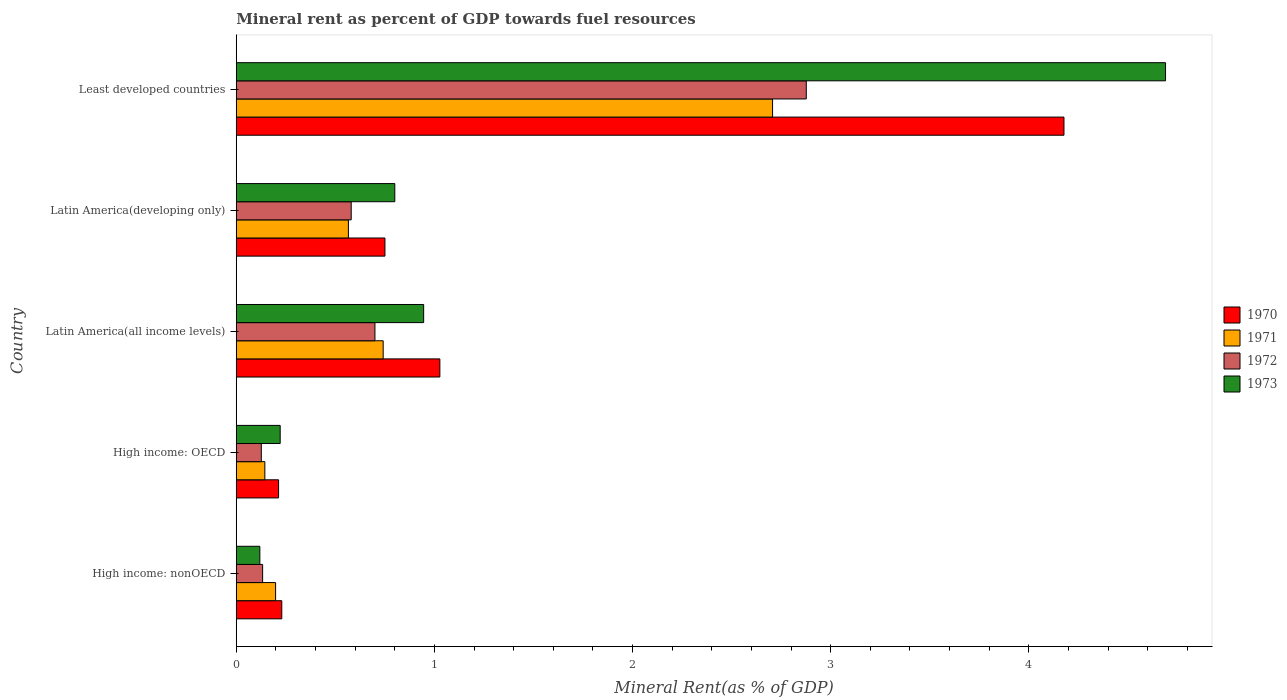How many different coloured bars are there?
Give a very brief answer. 4. Are the number of bars on each tick of the Y-axis equal?
Give a very brief answer. Yes. How many bars are there on the 4th tick from the top?
Offer a very short reply. 4. How many bars are there on the 1st tick from the bottom?
Your answer should be very brief. 4. What is the label of the 5th group of bars from the top?
Your answer should be compact. High income: nonOECD. What is the mineral rent in 1970 in High income: nonOECD?
Offer a terse response. 0.23. Across all countries, what is the maximum mineral rent in 1970?
Your answer should be compact. 4.18. Across all countries, what is the minimum mineral rent in 1971?
Give a very brief answer. 0.14. In which country was the mineral rent in 1970 maximum?
Your response must be concise. Least developed countries. In which country was the mineral rent in 1971 minimum?
Make the answer very short. High income: OECD. What is the total mineral rent in 1970 in the graph?
Offer a terse response. 6.4. What is the difference between the mineral rent in 1970 in High income: nonOECD and that in Latin America(developing only)?
Your response must be concise. -0.52. What is the difference between the mineral rent in 1971 in Latin America(all income levels) and the mineral rent in 1970 in Least developed countries?
Give a very brief answer. -3.44. What is the average mineral rent in 1972 per country?
Make the answer very short. 0.88. What is the difference between the mineral rent in 1970 and mineral rent in 1972 in Latin America(all income levels)?
Offer a very short reply. 0.33. What is the ratio of the mineral rent in 1971 in High income: nonOECD to that in Latin America(developing only)?
Your answer should be very brief. 0.35. Is the difference between the mineral rent in 1970 in Latin America(all income levels) and Latin America(developing only) greater than the difference between the mineral rent in 1972 in Latin America(all income levels) and Latin America(developing only)?
Ensure brevity in your answer.  Yes. What is the difference between the highest and the second highest mineral rent in 1972?
Offer a very short reply. 2.18. What is the difference between the highest and the lowest mineral rent in 1971?
Offer a very short reply. 2.56. Is the sum of the mineral rent in 1973 in High income: nonOECD and Least developed countries greater than the maximum mineral rent in 1971 across all countries?
Give a very brief answer. Yes. Is it the case that in every country, the sum of the mineral rent in 1973 and mineral rent in 1972 is greater than the sum of mineral rent in 1971 and mineral rent in 1970?
Your answer should be compact. No. Is it the case that in every country, the sum of the mineral rent in 1970 and mineral rent in 1971 is greater than the mineral rent in 1973?
Keep it short and to the point. Yes. How many countries are there in the graph?
Offer a terse response. 5. Does the graph contain any zero values?
Ensure brevity in your answer.  No. Does the graph contain grids?
Provide a succinct answer. No. Where does the legend appear in the graph?
Offer a very short reply. Center right. What is the title of the graph?
Make the answer very short. Mineral rent as percent of GDP towards fuel resources. Does "2009" appear as one of the legend labels in the graph?
Make the answer very short. No. What is the label or title of the X-axis?
Provide a short and direct response. Mineral Rent(as % of GDP). What is the label or title of the Y-axis?
Give a very brief answer. Country. What is the Mineral Rent(as % of GDP) of 1970 in High income: nonOECD?
Make the answer very short. 0.23. What is the Mineral Rent(as % of GDP) in 1971 in High income: nonOECD?
Your response must be concise. 0.2. What is the Mineral Rent(as % of GDP) in 1972 in High income: nonOECD?
Your answer should be compact. 0.13. What is the Mineral Rent(as % of GDP) of 1973 in High income: nonOECD?
Make the answer very short. 0.12. What is the Mineral Rent(as % of GDP) of 1970 in High income: OECD?
Give a very brief answer. 0.21. What is the Mineral Rent(as % of GDP) in 1971 in High income: OECD?
Make the answer very short. 0.14. What is the Mineral Rent(as % of GDP) in 1972 in High income: OECD?
Your response must be concise. 0.13. What is the Mineral Rent(as % of GDP) of 1973 in High income: OECD?
Provide a succinct answer. 0.22. What is the Mineral Rent(as % of GDP) in 1970 in Latin America(all income levels)?
Offer a very short reply. 1.03. What is the Mineral Rent(as % of GDP) in 1971 in Latin America(all income levels)?
Make the answer very short. 0.74. What is the Mineral Rent(as % of GDP) in 1972 in Latin America(all income levels)?
Provide a succinct answer. 0.7. What is the Mineral Rent(as % of GDP) of 1973 in Latin America(all income levels)?
Give a very brief answer. 0.95. What is the Mineral Rent(as % of GDP) in 1970 in Latin America(developing only)?
Your answer should be compact. 0.75. What is the Mineral Rent(as % of GDP) in 1971 in Latin America(developing only)?
Give a very brief answer. 0.57. What is the Mineral Rent(as % of GDP) in 1972 in Latin America(developing only)?
Give a very brief answer. 0.58. What is the Mineral Rent(as % of GDP) of 1973 in Latin America(developing only)?
Keep it short and to the point. 0.8. What is the Mineral Rent(as % of GDP) of 1970 in Least developed countries?
Make the answer very short. 4.18. What is the Mineral Rent(as % of GDP) in 1971 in Least developed countries?
Provide a succinct answer. 2.71. What is the Mineral Rent(as % of GDP) of 1972 in Least developed countries?
Make the answer very short. 2.88. What is the Mineral Rent(as % of GDP) of 1973 in Least developed countries?
Your answer should be compact. 4.69. Across all countries, what is the maximum Mineral Rent(as % of GDP) in 1970?
Offer a very short reply. 4.18. Across all countries, what is the maximum Mineral Rent(as % of GDP) of 1971?
Your response must be concise. 2.71. Across all countries, what is the maximum Mineral Rent(as % of GDP) in 1972?
Ensure brevity in your answer.  2.88. Across all countries, what is the maximum Mineral Rent(as % of GDP) in 1973?
Your response must be concise. 4.69. Across all countries, what is the minimum Mineral Rent(as % of GDP) of 1970?
Keep it short and to the point. 0.21. Across all countries, what is the minimum Mineral Rent(as % of GDP) in 1971?
Offer a terse response. 0.14. Across all countries, what is the minimum Mineral Rent(as % of GDP) of 1972?
Provide a short and direct response. 0.13. Across all countries, what is the minimum Mineral Rent(as % of GDP) of 1973?
Make the answer very short. 0.12. What is the total Mineral Rent(as % of GDP) in 1970 in the graph?
Keep it short and to the point. 6.4. What is the total Mineral Rent(as % of GDP) of 1971 in the graph?
Ensure brevity in your answer.  4.36. What is the total Mineral Rent(as % of GDP) in 1972 in the graph?
Your answer should be very brief. 4.42. What is the total Mineral Rent(as % of GDP) in 1973 in the graph?
Keep it short and to the point. 6.78. What is the difference between the Mineral Rent(as % of GDP) in 1970 in High income: nonOECD and that in High income: OECD?
Provide a short and direct response. 0.02. What is the difference between the Mineral Rent(as % of GDP) of 1971 in High income: nonOECD and that in High income: OECD?
Provide a succinct answer. 0.05. What is the difference between the Mineral Rent(as % of GDP) of 1972 in High income: nonOECD and that in High income: OECD?
Your answer should be compact. 0.01. What is the difference between the Mineral Rent(as % of GDP) in 1973 in High income: nonOECD and that in High income: OECD?
Offer a terse response. -0.1. What is the difference between the Mineral Rent(as % of GDP) of 1970 in High income: nonOECD and that in Latin America(all income levels)?
Make the answer very short. -0.8. What is the difference between the Mineral Rent(as % of GDP) in 1971 in High income: nonOECD and that in Latin America(all income levels)?
Give a very brief answer. -0.54. What is the difference between the Mineral Rent(as % of GDP) in 1972 in High income: nonOECD and that in Latin America(all income levels)?
Your response must be concise. -0.57. What is the difference between the Mineral Rent(as % of GDP) of 1973 in High income: nonOECD and that in Latin America(all income levels)?
Offer a very short reply. -0.83. What is the difference between the Mineral Rent(as % of GDP) in 1970 in High income: nonOECD and that in Latin America(developing only)?
Keep it short and to the point. -0.52. What is the difference between the Mineral Rent(as % of GDP) of 1971 in High income: nonOECD and that in Latin America(developing only)?
Ensure brevity in your answer.  -0.37. What is the difference between the Mineral Rent(as % of GDP) of 1972 in High income: nonOECD and that in Latin America(developing only)?
Ensure brevity in your answer.  -0.45. What is the difference between the Mineral Rent(as % of GDP) in 1973 in High income: nonOECD and that in Latin America(developing only)?
Make the answer very short. -0.68. What is the difference between the Mineral Rent(as % of GDP) of 1970 in High income: nonOECD and that in Least developed countries?
Make the answer very short. -3.95. What is the difference between the Mineral Rent(as % of GDP) in 1971 in High income: nonOECD and that in Least developed countries?
Make the answer very short. -2.51. What is the difference between the Mineral Rent(as % of GDP) of 1972 in High income: nonOECD and that in Least developed countries?
Your answer should be very brief. -2.74. What is the difference between the Mineral Rent(as % of GDP) in 1973 in High income: nonOECD and that in Least developed countries?
Make the answer very short. -4.57. What is the difference between the Mineral Rent(as % of GDP) in 1970 in High income: OECD and that in Latin America(all income levels)?
Your response must be concise. -0.81. What is the difference between the Mineral Rent(as % of GDP) in 1971 in High income: OECD and that in Latin America(all income levels)?
Give a very brief answer. -0.6. What is the difference between the Mineral Rent(as % of GDP) in 1972 in High income: OECD and that in Latin America(all income levels)?
Offer a very short reply. -0.57. What is the difference between the Mineral Rent(as % of GDP) in 1973 in High income: OECD and that in Latin America(all income levels)?
Provide a short and direct response. -0.72. What is the difference between the Mineral Rent(as % of GDP) of 1970 in High income: OECD and that in Latin America(developing only)?
Offer a very short reply. -0.54. What is the difference between the Mineral Rent(as % of GDP) in 1971 in High income: OECD and that in Latin America(developing only)?
Provide a short and direct response. -0.42. What is the difference between the Mineral Rent(as % of GDP) in 1972 in High income: OECD and that in Latin America(developing only)?
Your answer should be very brief. -0.45. What is the difference between the Mineral Rent(as % of GDP) in 1973 in High income: OECD and that in Latin America(developing only)?
Offer a very short reply. -0.58. What is the difference between the Mineral Rent(as % of GDP) of 1970 in High income: OECD and that in Least developed countries?
Offer a very short reply. -3.96. What is the difference between the Mineral Rent(as % of GDP) in 1971 in High income: OECD and that in Least developed countries?
Your answer should be very brief. -2.56. What is the difference between the Mineral Rent(as % of GDP) in 1972 in High income: OECD and that in Least developed countries?
Offer a terse response. -2.75. What is the difference between the Mineral Rent(as % of GDP) of 1973 in High income: OECD and that in Least developed countries?
Offer a very short reply. -4.47. What is the difference between the Mineral Rent(as % of GDP) of 1970 in Latin America(all income levels) and that in Latin America(developing only)?
Your answer should be very brief. 0.28. What is the difference between the Mineral Rent(as % of GDP) in 1971 in Latin America(all income levels) and that in Latin America(developing only)?
Give a very brief answer. 0.18. What is the difference between the Mineral Rent(as % of GDP) of 1972 in Latin America(all income levels) and that in Latin America(developing only)?
Offer a very short reply. 0.12. What is the difference between the Mineral Rent(as % of GDP) of 1973 in Latin America(all income levels) and that in Latin America(developing only)?
Your response must be concise. 0.15. What is the difference between the Mineral Rent(as % of GDP) of 1970 in Latin America(all income levels) and that in Least developed countries?
Ensure brevity in your answer.  -3.15. What is the difference between the Mineral Rent(as % of GDP) of 1971 in Latin America(all income levels) and that in Least developed countries?
Provide a succinct answer. -1.97. What is the difference between the Mineral Rent(as % of GDP) in 1972 in Latin America(all income levels) and that in Least developed countries?
Make the answer very short. -2.18. What is the difference between the Mineral Rent(as % of GDP) in 1973 in Latin America(all income levels) and that in Least developed countries?
Provide a short and direct response. -3.74. What is the difference between the Mineral Rent(as % of GDP) of 1970 in Latin America(developing only) and that in Least developed countries?
Offer a terse response. -3.43. What is the difference between the Mineral Rent(as % of GDP) of 1971 in Latin America(developing only) and that in Least developed countries?
Give a very brief answer. -2.14. What is the difference between the Mineral Rent(as % of GDP) in 1972 in Latin America(developing only) and that in Least developed countries?
Your answer should be compact. -2.3. What is the difference between the Mineral Rent(as % of GDP) in 1973 in Latin America(developing only) and that in Least developed countries?
Provide a succinct answer. -3.89. What is the difference between the Mineral Rent(as % of GDP) in 1970 in High income: nonOECD and the Mineral Rent(as % of GDP) in 1971 in High income: OECD?
Provide a short and direct response. 0.09. What is the difference between the Mineral Rent(as % of GDP) in 1970 in High income: nonOECD and the Mineral Rent(as % of GDP) in 1972 in High income: OECD?
Provide a succinct answer. 0.1. What is the difference between the Mineral Rent(as % of GDP) of 1970 in High income: nonOECD and the Mineral Rent(as % of GDP) of 1973 in High income: OECD?
Offer a very short reply. 0.01. What is the difference between the Mineral Rent(as % of GDP) in 1971 in High income: nonOECD and the Mineral Rent(as % of GDP) in 1972 in High income: OECD?
Your response must be concise. 0.07. What is the difference between the Mineral Rent(as % of GDP) of 1971 in High income: nonOECD and the Mineral Rent(as % of GDP) of 1973 in High income: OECD?
Your answer should be compact. -0.02. What is the difference between the Mineral Rent(as % of GDP) in 1972 in High income: nonOECD and the Mineral Rent(as % of GDP) in 1973 in High income: OECD?
Offer a terse response. -0.09. What is the difference between the Mineral Rent(as % of GDP) in 1970 in High income: nonOECD and the Mineral Rent(as % of GDP) in 1971 in Latin America(all income levels)?
Provide a succinct answer. -0.51. What is the difference between the Mineral Rent(as % of GDP) in 1970 in High income: nonOECD and the Mineral Rent(as % of GDP) in 1972 in Latin America(all income levels)?
Provide a succinct answer. -0.47. What is the difference between the Mineral Rent(as % of GDP) of 1970 in High income: nonOECD and the Mineral Rent(as % of GDP) of 1973 in Latin America(all income levels)?
Offer a very short reply. -0.72. What is the difference between the Mineral Rent(as % of GDP) of 1971 in High income: nonOECD and the Mineral Rent(as % of GDP) of 1972 in Latin America(all income levels)?
Your answer should be compact. -0.5. What is the difference between the Mineral Rent(as % of GDP) in 1971 in High income: nonOECD and the Mineral Rent(as % of GDP) in 1973 in Latin America(all income levels)?
Make the answer very short. -0.75. What is the difference between the Mineral Rent(as % of GDP) of 1972 in High income: nonOECD and the Mineral Rent(as % of GDP) of 1973 in Latin America(all income levels)?
Offer a terse response. -0.81. What is the difference between the Mineral Rent(as % of GDP) of 1970 in High income: nonOECD and the Mineral Rent(as % of GDP) of 1971 in Latin America(developing only)?
Provide a short and direct response. -0.34. What is the difference between the Mineral Rent(as % of GDP) in 1970 in High income: nonOECD and the Mineral Rent(as % of GDP) in 1972 in Latin America(developing only)?
Your answer should be compact. -0.35. What is the difference between the Mineral Rent(as % of GDP) in 1970 in High income: nonOECD and the Mineral Rent(as % of GDP) in 1973 in Latin America(developing only)?
Provide a succinct answer. -0.57. What is the difference between the Mineral Rent(as % of GDP) of 1971 in High income: nonOECD and the Mineral Rent(as % of GDP) of 1972 in Latin America(developing only)?
Provide a short and direct response. -0.38. What is the difference between the Mineral Rent(as % of GDP) in 1971 in High income: nonOECD and the Mineral Rent(as % of GDP) in 1973 in Latin America(developing only)?
Your answer should be very brief. -0.6. What is the difference between the Mineral Rent(as % of GDP) in 1972 in High income: nonOECD and the Mineral Rent(as % of GDP) in 1973 in Latin America(developing only)?
Your response must be concise. -0.67. What is the difference between the Mineral Rent(as % of GDP) in 1970 in High income: nonOECD and the Mineral Rent(as % of GDP) in 1971 in Least developed countries?
Offer a terse response. -2.48. What is the difference between the Mineral Rent(as % of GDP) of 1970 in High income: nonOECD and the Mineral Rent(as % of GDP) of 1972 in Least developed countries?
Your answer should be very brief. -2.65. What is the difference between the Mineral Rent(as % of GDP) in 1970 in High income: nonOECD and the Mineral Rent(as % of GDP) in 1973 in Least developed countries?
Your answer should be very brief. -4.46. What is the difference between the Mineral Rent(as % of GDP) of 1971 in High income: nonOECD and the Mineral Rent(as % of GDP) of 1972 in Least developed countries?
Provide a short and direct response. -2.68. What is the difference between the Mineral Rent(as % of GDP) of 1971 in High income: nonOECD and the Mineral Rent(as % of GDP) of 1973 in Least developed countries?
Your answer should be very brief. -4.49. What is the difference between the Mineral Rent(as % of GDP) of 1972 in High income: nonOECD and the Mineral Rent(as % of GDP) of 1973 in Least developed countries?
Your answer should be compact. -4.56. What is the difference between the Mineral Rent(as % of GDP) of 1970 in High income: OECD and the Mineral Rent(as % of GDP) of 1971 in Latin America(all income levels)?
Ensure brevity in your answer.  -0.53. What is the difference between the Mineral Rent(as % of GDP) in 1970 in High income: OECD and the Mineral Rent(as % of GDP) in 1972 in Latin America(all income levels)?
Keep it short and to the point. -0.49. What is the difference between the Mineral Rent(as % of GDP) in 1970 in High income: OECD and the Mineral Rent(as % of GDP) in 1973 in Latin America(all income levels)?
Provide a short and direct response. -0.73. What is the difference between the Mineral Rent(as % of GDP) in 1971 in High income: OECD and the Mineral Rent(as % of GDP) in 1972 in Latin America(all income levels)?
Your answer should be compact. -0.56. What is the difference between the Mineral Rent(as % of GDP) in 1971 in High income: OECD and the Mineral Rent(as % of GDP) in 1973 in Latin America(all income levels)?
Your response must be concise. -0.8. What is the difference between the Mineral Rent(as % of GDP) in 1972 in High income: OECD and the Mineral Rent(as % of GDP) in 1973 in Latin America(all income levels)?
Your answer should be very brief. -0.82. What is the difference between the Mineral Rent(as % of GDP) of 1970 in High income: OECD and the Mineral Rent(as % of GDP) of 1971 in Latin America(developing only)?
Provide a short and direct response. -0.35. What is the difference between the Mineral Rent(as % of GDP) in 1970 in High income: OECD and the Mineral Rent(as % of GDP) in 1972 in Latin America(developing only)?
Offer a very short reply. -0.37. What is the difference between the Mineral Rent(as % of GDP) in 1970 in High income: OECD and the Mineral Rent(as % of GDP) in 1973 in Latin America(developing only)?
Give a very brief answer. -0.59. What is the difference between the Mineral Rent(as % of GDP) in 1971 in High income: OECD and the Mineral Rent(as % of GDP) in 1972 in Latin America(developing only)?
Provide a short and direct response. -0.44. What is the difference between the Mineral Rent(as % of GDP) of 1971 in High income: OECD and the Mineral Rent(as % of GDP) of 1973 in Latin America(developing only)?
Your response must be concise. -0.66. What is the difference between the Mineral Rent(as % of GDP) of 1972 in High income: OECD and the Mineral Rent(as % of GDP) of 1973 in Latin America(developing only)?
Offer a very short reply. -0.67. What is the difference between the Mineral Rent(as % of GDP) of 1970 in High income: OECD and the Mineral Rent(as % of GDP) of 1971 in Least developed countries?
Give a very brief answer. -2.49. What is the difference between the Mineral Rent(as % of GDP) of 1970 in High income: OECD and the Mineral Rent(as % of GDP) of 1972 in Least developed countries?
Provide a short and direct response. -2.66. What is the difference between the Mineral Rent(as % of GDP) of 1970 in High income: OECD and the Mineral Rent(as % of GDP) of 1973 in Least developed countries?
Your answer should be very brief. -4.48. What is the difference between the Mineral Rent(as % of GDP) in 1971 in High income: OECD and the Mineral Rent(as % of GDP) in 1972 in Least developed countries?
Your answer should be very brief. -2.73. What is the difference between the Mineral Rent(as % of GDP) of 1971 in High income: OECD and the Mineral Rent(as % of GDP) of 1973 in Least developed countries?
Make the answer very short. -4.55. What is the difference between the Mineral Rent(as % of GDP) of 1972 in High income: OECD and the Mineral Rent(as % of GDP) of 1973 in Least developed countries?
Your response must be concise. -4.56. What is the difference between the Mineral Rent(as % of GDP) of 1970 in Latin America(all income levels) and the Mineral Rent(as % of GDP) of 1971 in Latin America(developing only)?
Your answer should be compact. 0.46. What is the difference between the Mineral Rent(as % of GDP) in 1970 in Latin America(all income levels) and the Mineral Rent(as % of GDP) in 1972 in Latin America(developing only)?
Make the answer very short. 0.45. What is the difference between the Mineral Rent(as % of GDP) of 1970 in Latin America(all income levels) and the Mineral Rent(as % of GDP) of 1973 in Latin America(developing only)?
Make the answer very short. 0.23. What is the difference between the Mineral Rent(as % of GDP) in 1971 in Latin America(all income levels) and the Mineral Rent(as % of GDP) in 1972 in Latin America(developing only)?
Offer a terse response. 0.16. What is the difference between the Mineral Rent(as % of GDP) of 1971 in Latin America(all income levels) and the Mineral Rent(as % of GDP) of 1973 in Latin America(developing only)?
Provide a short and direct response. -0.06. What is the difference between the Mineral Rent(as % of GDP) in 1972 in Latin America(all income levels) and the Mineral Rent(as % of GDP) in 1973 in Latin America(developing only)?
Ensure brevity in your answer.  -0.1. What is the difference between the Mineral Rent(as % of GDP) of 1970 in Latin America(all income levels) and the Mineral Rent(as % of GDP) of 1971 in Least developed countries?
Make the answer very short. -1.68. What is the difference between the Mineral Rent(as % of GDP) in 1970 in Latin America(all income levels) and the Mineral Rent(as % of GDP) in 1972 in Least developed countries?
Ensure brevity in your answer.  -1.85. What is the difference between the Mineral Rent(as % of GDP) of 1970 in Latin America(all income levels) and the Mineral Rent(as % of GDP) of 1973 in Least developed countries?
Your answer should be very brief. -3.66. What is the difference between the Mineral Rent(as % of GDP) of 1971 in Latin America(all income levels) and the Mineral Rent(as % of GDP) of 1972 in Least developed countries?
Offer a terse response. -2.14. What is the difference between the Mineral Rent(as % of GDP) in 1971 in Latin America(all income levels) and the Mineral Rent(as % of GDP) in 1973 in Least developed countries?
Keep it short and to the point. -3.95. What is the difference between the Mineral Rent(as % of GDP) in 1972 in Latin America(all income levels) and the Mineral Rent(as % of GDP) in 1973 in Least developed countries?
Offer a terse response. -3.99. What is the difference between the Mineral Rent(as % of GDP) of 1970 in Latin America(developing only) and the Mineral Rent(as % of GDP) of 1971 in Least developed countries?
Your answer should be very brief. -1.96. What is the difference between the Mineral Rent(as % of GDP) in 1970 in Latin America(developing only) and the Mineral Rent(as % of GDP) in 1972 in Least developed countries?
Ensure brevity in your answer.  -2.13. What is the difference between the Mineral Rent(as % of GDP) in 1970 in Latin America(developing only) and the Mineral Rent(as % of GDP) in 1973 in Least developed countries?
Offer a very short reply. -3.94. What is the difference between the Mineral Rent(as % of GDP) in 1971 in Latin America(developing only) and the Mineral Rent(as % of GDP) in 1972 in Least developed countries?
Offer a terse response. -2.31. What is the difference between the Mineral Rent(as % of GDP) in 1971 in Latin America(developing only) and the Mineral Rent(as % of GDP) in 1973 in Least developed countries?
Offer a very short reply. -4.12. What is the difference between the Mineral Rent(as % of GDP) of 1972 in Latin America(developing only) and the Mineral Rent(as % of GDP) of 1973 in Least developed countries?
Make the answer very short. -4.11. What is the average Mineral Rent(as % of GDP) of 1970 per country?
Keep it short and to the point. 1.28. What is the average Mineral Rent(as % of GDP) in 1971 per country?
Give a very brief answer. 0.87. What is the average Mineral Rent(as % of GDP) of 1972 per country?
Give a very brief answer. 0.88. What is the average Mineral Rent(as % of GDP) of 1973 per country?
Your response must be concise. 1.36. What is the difference between the Mineral Rent(as % of GDP) of 1970 and Mineral Rent(as % of GDP) of 1971 in High income: nonOECD?
Offer a very short reply. 0.03. What is the difference between the Mineral Rent(as % of GDP) in 1970 and Mineral Rent(as % of GDP) in 1972 in High income: nonOECD?
Your answer should be compact. 0.1. What is the difference between the Mineral Rent(as % of GDP) of 1970 and Mineral Rent(as % of GDP) of 1973 in High income: nonOECD?
Your answer should be very brief. 0.11. What is the difference between the Mineral Rent(as % of GDP) in 1971 and Mineral Rent(as % of GDP) in 1972 in High income: nonOECD?
Ensure brevity in your answer.  0.07. What is the difference between the Mineral Rent(as % of GDP) in 1971 and Mineral Rent(as % of GDP) in 1973 in High income: nonOECD?
Offer a very short reply. 0.08. What is the difference between the Mineral Rent(as % of GDP) in 1972 and Mineral Rent(as % of GDP) in 1973 in High income: nonOECD?
Ensure brevity in your answer.  0.01. What is the difference between the Mineral Rent(as % of GDP) of 1970 and Mineral Rent(as % of GDP) of 1971 in High income: OECD?
Ensure brevity in your answer.  0.07. What is the difference between the Mineral Rent(as % of GDP) in 1970 and Mineral Rent(as % of GDP) in 1972 in High income: OECD?
Offer a very short reply. 0.09. What is the difference between the Mineral Rent(as % of GDP) in 1970 and Mineral Rent(as % of GDP) in 1973 in High income: OECD?
Your response must be concise. -0.01. What is the difference between the Mineral Rent(as % of GDP) in 1971 and Mineral Rent(as % of GDP) in 1972 in High income: OECD?
Provide a short and direct response. 0.02. What is the difference between the Mineral Rent(as % of GDP) in 1971 and Mineral Rent(as % of GDP) in 1973 in High income: OECD?
Offer a terse response. -0.08. What is the difference between the Mineral Rent(as % of GDP) in 1972 and Mineral Rent(as % of GDP) in 1973 in High income: OECD?
Provide a succinct answer. -0.1. What is the difference between the Mineral Rent(as % of GDP) of 1970 and Mineral Rent(as % of GDP) of 1971 in Latin America(all income levels)?
Your answer should be compact. 0.29. What is the difference between the Mineral Rent(as % of GDP) in 1970 and Mineral Rent(as % of GDP) in 1972 in Latin America(all income levels)?
Offer a terse response. 0.33. What is the difference between the Mineral Rent(as % of GDP) in 1970 and Mineral Rent(as % of GDP) in 1973 in Latin America(all income levels)?
Provide a short and direct response. 0.08. What is the difference between the Mineral Rent(as % of GDP) in 1971 and Mineral Rent(as % of GDP) in 1972 in Latin America(all income levels)?
Provide a short and direct response. 0.04. What is the difference between the Mineral Rent(as % of GDP) of 1971 and Mineral Rent(as % of GDP) of 1973 in Latin America(all income levels)?
Provide a succinct answer. -0.2. What is the difference between the Mineral Rent(as % of GDP) of 1972 and Mineral Rent(as % of GDP) of 1973 in Latin America(all income levels)?
Provide a succinct answer. -0.25. What is the difference between the Mineral Rent(as % of GDP) in 1970 and Mineral Rent(as % of GDP) in 1971 in Latin America(developing only)?
Keep it short and to the point. 0.18. What is the difference between the Mineral Rent(as % of GDP) in 1970 and Mineral Rent(as % of GDP) in 1972 in Latin America(developing only)?
Offer a terse response. 0.17. What is the difference between the Mineral Rent(as % of GDP) of 1970 and Mineral Rent(as % of GDP) of 1973 in Latin America(developing only)?
Provide a short and direct response. -0.05. What is the difference between the Mineral Rent(as % of GDP) of 1971 and Mineral Rent(as % of GDP) of 1972 in Latin America(developing only)?
Keep it short and to the point. -0.01. What is the difference between the Mineral Rent(as % of GDP) in 1971 and Mineral Rent(as % of GDP) in 1973 in Latin America(developing only)?
Your answer should be very brief. -0.23. What is the difference between the Mineral Rent(as % of GDP) of 1972 and Mineral Rent(as % of GDP) of 1973 in Latin America(developing only)?
Offer a terse response. -0.22. What is the difference between the Mineral Rent(as % of GDP) of 1970 and Mineral Rent(as % of GDP) of 1971 in Least developed countries?
Your response must be concise. 1.47. What is the difference between the Mineral Rent(as % of GDP) of 1970 and Mineral Rent(as % of GDP) of 1972 in Least developed countries?
Make the answer very short. 1.3. What is the difference between the Mineral Rent(as % of GDP) of 1970 and Mineral Rent(as % of GDP) of 1973 in Least developed countries?
Provide a succinct answer. -0.51. What is the difference between the Mineral Rent(as % of GDP) in 1971 and Mineral Rent(as % of GDP) in 1972 in Least developed countries?
Make the answer very short. -0.17. What is the difference between the Mineral Rent(as % of GDP) of 1971 and Mineral Rent(as % of GDP) of 1973 in Least developed countries?
Provide a short and direct response. -1.98. What is the difference between the Mineral Rent(as % of GDP) of 1972 and Mineral Rent(as % of GDP) of 1973 in Least developed countries?
Make the answer very short. -1.81. What is the ratio of the Mineral Rent(as % of GDP) of 1970 in High income: nonOECD to that in High income: OECD?
Offer a terse response. 1.08. What is the ratio of the Mineral Rent(as % of GDP) in 1971 in High income: nonOECD to that in High income: OECD?
Make the answer very short. 1.38. What is the ratio of the Mineral Rent(as % of GDP) in 1972 in High income: nonOECD to that in High income: OECD?
Your answer should be compact. 1.05. What is the ratio of the Mineral Rent(as % of GDP) in 1973 in High income: nonOECD to that in High income: OECD?
Provide a succinct answer. 0.54. What is the ratio of the Mineral Rent(as % of GDP) of 1970 in High income: nonOECD to that in Latin America(all income levels)?
Make the answer very short. 0.22. What is the ratio of the Mineral Rent(as % of GDP) of 1971 in High income: nonOECD to that in Latin America(all income levels)?
Offer a very short reply. 0.27. What is the ratio of the Mineral Rent(as % of GDP) in 1972 in High income: nonOECD to that in Latin America(all income levels)?
Provide a short and direct response. 0.19. What is the ratio of the Mineral Rent(as % of GDP) of 1973 in High income: nonOECD to that in Latin America(all income levels)?
Ensure brevity in your answer.  0.13. What is the ratio of the Mineral Rent(as % of GDP) of 1970 in High income: nonOECD to that in Latin America(developing only)?
Provide a short and direct response. 0.31. What is the ratio of the Mineral Rent(as % of GDP) of 1971 in High income: nonOECD to that in Latin America(developing only)?
Make the answer very short. 0.35. What is the ratio of the Mineral Rent(as % of GDP) of 1972 in High income: nonOECD to that in Latin America(developing only)?
Make the answer very short. 0.23. What is the ratio of the Mineral Rent(as % of GDP) of 1973 in High income: nonOECD to that in Latin America(developing only)?
Keep it short and to the point. 0.15. What is the ratio of the Mineral Rent(as % of GDP) of 1970 in High income: nonOECD to that in Least developed countries?
Your answer should be very brief. 0.06. What is the ratio of the Mineral Rent(as % of GDP) in 1971 in High income: nonOECD to that in Least developed countries?
Your answer should be very brief. 0.07. What is the ratio of the Mineral Rent(as % of GDP) in 1972 in High income: nonOECD to that in Least developed countries?
Your answer should be very brief. 0.05. What is the ratio of the Mineral Rent(as % of GDP) in 1973 in High income: nonOECD to that in Least developed countries?
Keep it short and to the point. 0.03. What is the ratio of the Mineral Rent(as % of GDP) of 1970 in High income: OECD to that in Latin America(all income levels)?
Keep it short and to the point. 0.21. What is the ratio of the Mineral Rent(as % of GDP) in 1971 in High income: OECD to that in Latin America(all income levels)?
Make the answer very short. 0.19. What is the ratio of the Mineral Rent(as % of GDP) of 1972 in High income: OECD to that in Latin America(all income levels)?
Your answer should be very brief. 0.18. What is the ratio of the Mineral Rent(as % of GDP) of 1973 in High income: OECD to that in Latin America(all income levels)?
Your answer should be compact. 0.23. What is the ratio of the Mineral Rent(as % of GDP) of 1970 in High income: OECD to that in Latin America(developing only)?
Keep it short and to the point. 0.28. What is the ratio of the Mineral Rent(as % of GDP) in 1971 in High income: OECD to that in Latin America(developing only)?
Make the answer very short. 0.26. What is the ratio of the Mineral Rent(as % of GDP) of 1972 in High income: OECD to that in Latin America(developing only)?
Give a very brief answer. 0.22. What is the ratio of the Mineral Rent(as % of GDP) in 1973 in High income: OECD to that in Latin America(developing only)?
Give a very brief answer. 0.28. What is the ratio of the Mineral Rent(as % of GDP) of 1970 in High income: OECD to that in Least developed countries?
Your answer should be very brief. 0.05. What is the ratio of the Mineral Rent(as % of GDP) of 1971 in High income: OECD to that in Least developed countries?
Your response must be concise. 0.05. What is the ratio of the Mineral Rent(as % of GDP) in 1972 in High income: OECD to that in Least developed countries?
Ensure brevity in your answer.  0.04. What is the ratio of the Mineral Rent(as % of GDP) in 1973 in High income: OECD to that in Least developed countries?
Keep it short and to the point. 0.05. What is the ratio of the Mineral Rent(as % of GDP) in 1970 in Latin America(all income levels) to that in Latin America(developing only)?
Make the answer very short. 1.37. What is the ratio of the Mineral Rent(as % of GDP) in 1971 in Latin America(all income levels) to that in Latin America(developing only)?
Give a very brief answer. 1.31. What is the ratio of the Mineral Rent(as % of GDP) of 1972 in Latin America(all income levels) to that in Latin America(developing only)?
Ensure brevity in your answer.  1.21. What is the ratio of the Mineral Rent(as % of GDP) in 1973 in Latin America(all income levels) to that in Latin America(developing only)?
Your answer should be compact. 1.18. What is the ratio of the Mineral Rent(as % of GDP) in 1970 in Latin America(all income levels) to that in Least developed countries?
Keep it short and to the point. 0.25. What is the ratio of the Mineral Rent(as % of GDP) of 1971 in Latin America(all income levels) to that in Least developed countries?
Ensure brevity in your answer.  0.27. What is the ratio of the Mineral Rent(as % of GDP) of 1972 in Latin America(all income levels) to that in Least developed countries?
Offer a very short reply. 0.24. What is the ratio of the Mineral Rent(as % of GDP) of 1973 in Latin America(all income levels) to that in Least developed countries?
Offer a terse response. 0.2. What is the ratio of the Mineral Rent(as % of GDP) in 1970 in Latin America(developing only) to that in Least developed countries?
Give a very brief answer. 0.18. What is the ratio of the Mineral Rent(as % of GDP) in 1971 in Latin America(developing only) to that in Least developed countries?
Your answer should be very brief. 0.21. What is the ratio of the Mineral Rent(as % of GDP) in 1972 in Latin America(developing only) to that in Least developed countries?
Your answer should be compact. 0.2. What is the ratio of the Mineral Rent(as % of GDP) in 1973 in Latin America(developing only) to that in Least developed countries?
Your answer should be very brief. 0.17. What is the difference between the highest and the second highest Mineral Rent(as % of GDP) in 1970?
Offer a terse response. 3.15. What is the difference between the highest and the second highest Mineral Rent(as % of GDP) in 1971?
Offer a very short reply. 1.97. What is the difference between the highest and the second highest Mineral Rent(as % of GDP) in 1972?
Make the answer very short. 2.18. What is the difference between the highest and the second highest Mineral Rent(as % of GDP) in 1973?
Offer a terse response. 3.74. What is the difference between the highest and the lowest Mineral Rent(as % of GDP) in 1970?
Offer a terse response. 3.96. What is the difference between the highest and the lowest Mineral Rent(as % of GDP) in 1971?
Make the answer very short. 2.56. What is the difference between the highest and the lowest Mineral Rent(as % of GDP) of 1972?
Offer a terse response. 2.75. What is the difference between the highest and the lowest Mineral Rent(as % of GDP) of 1973?
Ensure brevity in your answer.  4.57. 